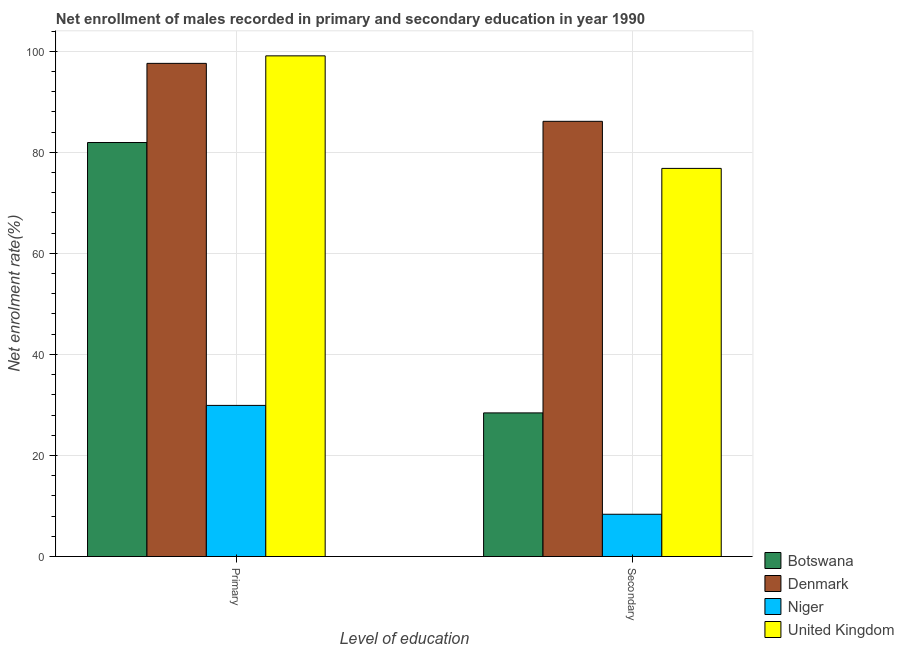How many groups of bars are there?
Your response must be concise. 2. Are the number of bars per tick equal to the number of legend labels?
Offer a terse response. Yes. How many bars are there on the 2nd tick from the right?
Your answer should be compact. 4. What is the label of the 1st group of bars from the left?
Provide a short and direct response. Primary. What is the enrollment rate in secondary education in Botswana?
Give a very brief answer. 28.42. Across all countries, what is the maximum enrollment rate in primary education?
Your answer should be very brief. 99.08. Across all countries, what is the minimum enrollment rate in primary education?
Your answer should be very brief. 29.91. In which country was the enrollment rate in primary education minimum?
Offer a terse response. Niger. What is the total enrollment rate in primary education in the graph?
Give a very brief answer. 308.52. What is the difference between the enrollment rate in secondary education in Denmark and that in Niger?
Provide a short and direct response. 77.76. What is the difference between the enrollment rate in primary education in Denmark and the enrollment rate in secondary education in United Kingdom?
Provide a short and direct response. 20.79. What is the average enrollment rate in secondary education per country?
Your answer should be very brief. 49.93. What is the difference between the enrollment rate in secondary education and enrollment rate in primary education in United Kingdom?
Make the answer very short. -22.27. In how many countries, is the enrollment rate in primary education greater than 4 %?
Provide a short and direct response. 4. What is the ratio of the enrollment rate in secondary education in Botswana to that in Denmark?
Provide a succinct answer. 0.33. In how many countries, is the enrollment rate in primary education greater than the average enrollment rate in primary education taken over all countries?
Give a very brief answer. 3. What does the 3rd bar from the left in Primary represents?
Offer a terse response. Niger. What does the 2nd bar from the right in Secondary represents?
Your answer should be compact. Niger. Are all the bars in the graph horizontal?
Make the answer very short. No. What is the difference between two consecutive major ticks on the Y-axis?
Your answer should be compact. 20. Are the values on the major ticks of Y-axis written in scientific E-notation?
Your answer should be very brief. No. What is the title of the graph?
Your answer should be very brief. Net enrollment of males recorded in primary and secondary education in year 1990. What is the label or title of the X-axis?
Your answer should be very brief. Level of education. What is the label or title of the Y-axis?
Offer a terse response. Net enrolment rate(%). What is the Net enrolment rate(%) of Botswana in Primary?
Give a very brief answer. 81.93. What is the Net enrolment rate(%) in Denmark in Primary?
Offer a terse response. 97.6. What is the Net enrolment rate(%) of Niger in Primary?
Your answer should be compact. 29.91. What is the Net enrolment rate(%) in United Kingdom in Primary?
Your answer should be very brief. 99.08. What is the Net enrolment rate(%) in Botswana in Secondary?
Your response must be concise. 28.42. What is the Net enrolment rate(%) of Denmark in Secondary?
Provide a short and direct response. 86.13. What is the Net enrolment rate(%) of Niger in Secondary?
Make the answer very short. 8.37. What is the Net enrolment rate(%) in United Kingdom in Secondary?
Offer a terse response. 76.81. Across all Level of education, what is the maximum Net enrolment rate(%) of Botswana?
Provide a short and direct response. 81.93. Across all Level of education, what is the maximum Net enrolment rate(%) in Denmark?
Provide a succinct answer. 97.6. Across all Level of education, what is the maximum Net enrolment rate(%) of Niger?
Offer a very short reply. 29.91. Across all Level of education, what is the maximum Net enrolment rate(%) of United Kingdom?
Your response must be concise. 99.08. Across all Level of education, what is the minimum Net enrolment rate(%) in Botswana?
Give a very brief answer. 28.42. Across all Level of education, what is the minimum Net enrolment rate(%) of Denmark?
Your answer should be compact. 86.13. Across all Level of education, what is the minimum Net enrolment rate(%) of Niger?
Give a very brief answer. 8.37. Across all Level of education, what is the minimum Net enrolment rate(%) of United Kingdom?
Offer a terse response. 76.81. What is the total Net enrolment rate(%) in Botswana in the graph?
Make the answer very short. 110.36. What is the total Net enrolment rate(%) in Denmark in the graph?
Your answer should be compact. 183.72. What is the total Net enrolment rate(%) in Niger in the graph?
Keep it short and to the point. 38.27. What is the total Net enrolment rate(%) of United Kingdom in the graph?
Your answer should be compact. 175.89. What is the difference between the Net enrolment rate(%) of Botswana in Primary and that in Secondary?
Keep it short and to the point. 53.51. What is the difference between the Net enrolment rate(%) of Denmark in Primary and that in Secondary?
Keep it short and to the point. 11.47. What is the difference between the Net enrolment rate(%) of Niger in Primary and that in Secondary?
Provide a succinct answer. 21.54. What is the difference between the Net enrolment rate(%) in United Kingdom in Primary and that in Secondary?
Your answer should be very brief. 22.27. What is the difference between the Net enrolment rate(%) of Botswana in Primary and the Net enrolment rate(%) of Denmark in Secondary?
Offer a very short reply. -4.2. What is the difference between the Net enrolment rate(%) of Botswana in Primary and the Net enrolment rate(%) of Niger in Secondary?
Your answer should be very brief. 73.57. What is the difference between the Net enrolment rate(%) of Botswana in Primary and the Net enrolment rate(%) of United Kingdom in Secondary?
Offer a very short reply. 5.12. What is the difference between the Net enrolment rate(%) in Denmark in Primary and the Net enrolment rate(%) in Niger in Secondary?
Keep it short and to the point. 89.23. What is the difference between the Net enrolment rate(%) of Denmark in Primary and the Net enrolment rate(%) of United Kingdom in Secondary?
Keep it short and to the point. 20.79. What is the difference between the Net enrolment rate(%) in Niger in Primary and the Net enrolment rate(%) in United Kingdom in Secondary?
Your response must be concise. -46.9. What is the average Net enrolment rate(%) in Botswana per Level of education?
Your answer should be compact. 55.18. What is the average Net enrolment rate(%) of Denmark per Level of education?
Your answer should be very brief. 91.86. What is the average Net enrolment rate(%) of Niger per Level of education?
Give a very brief answer. 19.14. What is the average Net enrolment rate(%) of United Kingdom per Level of education?
Your answer should be compact. 87.95. What is the difference between the Net enrolment rate(%) in Botswana and Net enrolment rate(%) in Denmark in Primary?
Provide a succinct answer. -15.67. What is the difference between the Net enrolment rate(%) in Botswana and Net enrolment rate(%) in Niger in Primary?
Your answer should be compact. 52.02. What is the difference between the Net enrolment rate(%) of Botswana and Net enrolment rate(%) of United Kingdom in Primary?
Provide a short and direct response. -17.15. What is the difference between the Net enrolment rate(%) of Denmark and Net enrolment rate(%) of Niger in Primary?
Your response must be concise. 67.69. What is the difference between the Net enrolment rate(%) of Denmark and Net enrolment rate(%) of United Kingdom in Primary?
Provide a short and direct response. -1.49. What is the difference between the Net enrolment rate(%) in Niger and Net enrolment rate(%) in United Kingdom in Primary?
Ensure brevity in your answer.  -69.18. What is the difference between the Net enrolment rate(%) of Botswana and Net enrolment rate(%) of Denmark in Secondary?
Your answer should be very brief. -57.7. What is the difference between the Net enrolment rate(%) in Botswana and Net enrolment rate(%) in Niger in Secondary?
Make the answer very short. 20.06. What is the difference between the Net enrolment rate(%) in Botswana and Net enrolment rate(%) in United Kingdom in Secondary?
Your answer should be compact. -48.39. What is the difference between the Net enrolment rate(%) in Denmark and Net enrolment rate(%) in Niger in Secondary?
Your response must be concise. 77.76. What is the difference between the Net enrolment rate(%) in Denmark and Net enrolment rate(%) in United Kingdom in Secondary?
Provide a short and direct response. 9.32. What is the difference between the Net enrolment rate(%) of Niger and Net enrolment rate(%) of United Kingdom in Secondary?
Your answer should be very brief. -68.45. What is the ratio of the Net enrolment rate(%) in Botswana in Primary to that in Secondary?
Ensure brevity in your answer.  2.88. What is the ratio of the Net enrolment rate(%) in Denmark in Primary to that in Secondary?
Ensure brevity in your answer.  1.13. What is the ratio of the Net enrolment rate(%) in Niger in Primary to that in Secondary?
Ensure brevity in your answer.  3.58. What is the ratio of the Net enrolment rate(%) of United Kingdom in Primary to that in Secondary?
Give a very brief answer. 1.29. What is the difference between the highest and the second highest Net enrolment rate(%) of Botswana?
Give a very brief answer. 53.51. What is the difference between the highest and the second highest Net enrolment rate(%) of Denmark?
Make the answer very short. 11.47. What is the difference between the highest and the second highest Net enrolment rate(%) in Niger?
Your answer should be very brief. 21.54. What is the difference between the highest and the second highest Net enrolment rate(%) in United Kingdom?
Give a very brief answer. 22.27. What is the difference between the highest and the lowest Net enrolment rate(%) in Botswana?
Ensure brevity in your answer.  53.51. What is the difference between the highest and the lowest Net enrolment rate(%) of Denmark?
Give a very brief answer. 11.47. What is the difference between the highest and the lowest Net enrolment rate(%) of Niger?
Offer a terse response. 21.54. What is the difference between the highest and the lowest Net enrolment rate(%) in United Kingdom?
Provide a succinct answer. 22.27. 